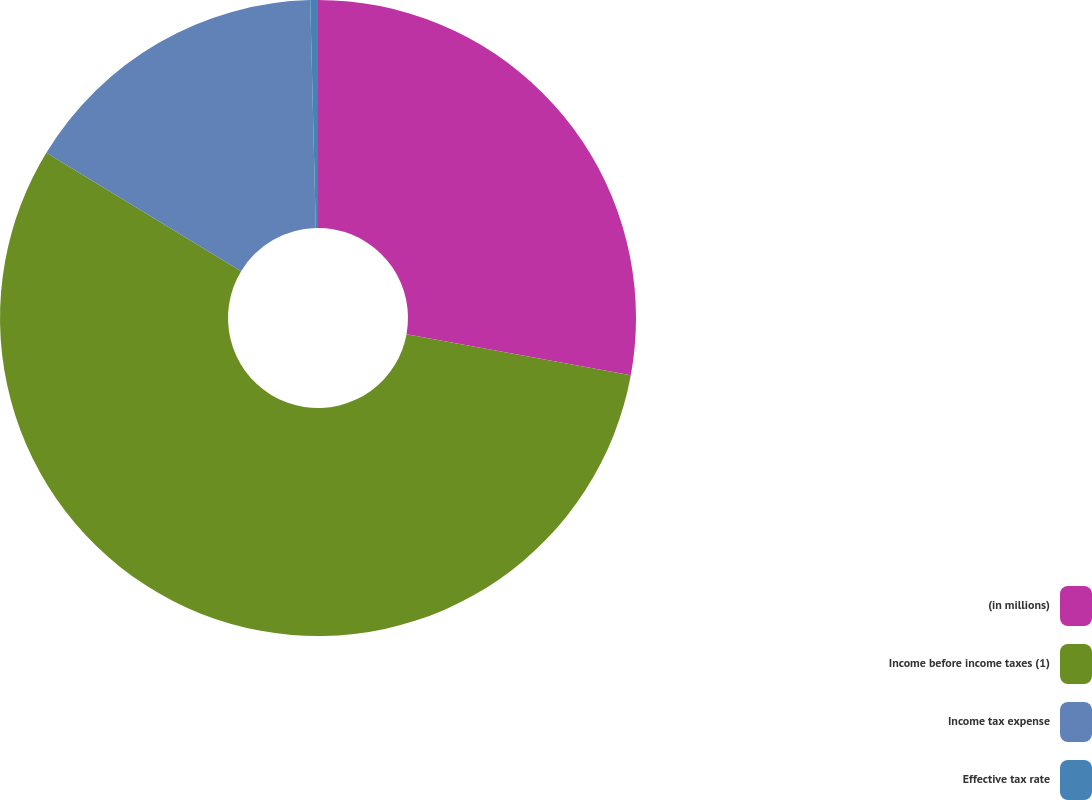Convert chart to OTSL. <chart><loc_0><loc_0><loc_500><loc_500><pie_chart><fcel>(in millions)<fcel>Income before income taxes (1)<fcel>Income tax expense<fcel>Effective tax rate<nl><fcel>27.88%<fcel>55.82%<fcel>15.91%<fcel>0.39%<nl></chart> 